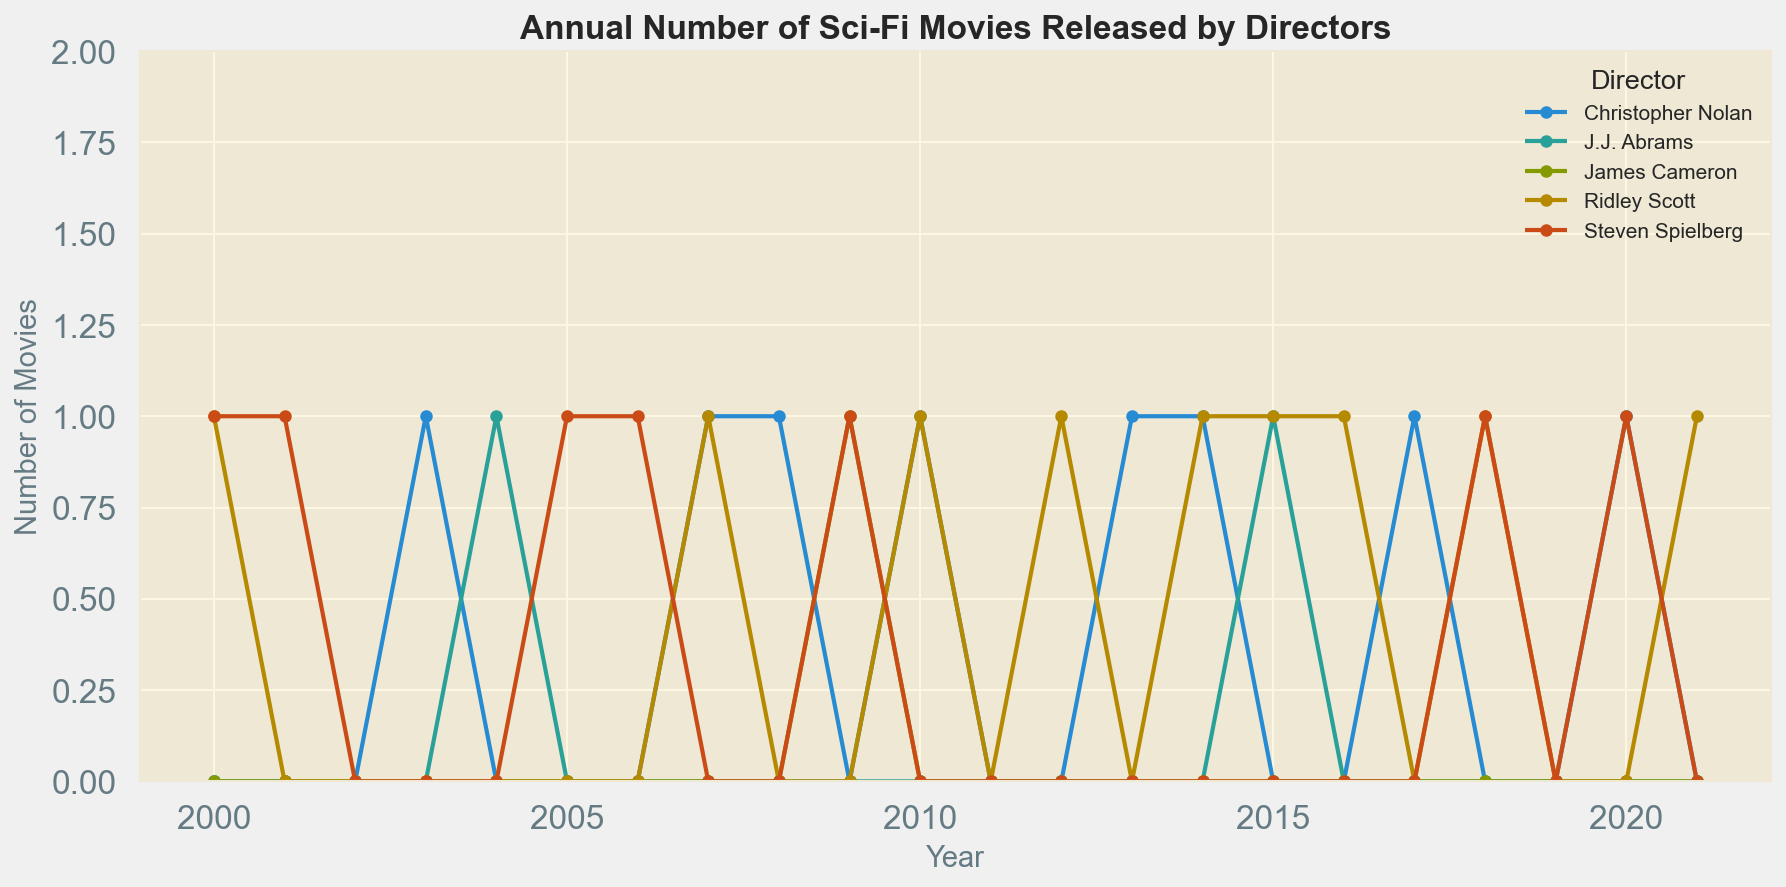What is the annual trend in the number of sci-fi movies released by Steven Spielberg from 2000 to 2021? Look at the line representing Steven Spielberg in the figure. Starting at one movie in 2000, the trend fluctuates with occasional years having one movie (2001, 2005, 2006, 2009, 2018, 2020) while most years have zero movies.
Answer: The trend fluctuates with a mix of zero and one movie, no clear upward or downward trend How did the number of sci-fi movies released by Christopher Nolan change between 2007 and 2010? Check the plot for Christopher Nolan. In 2007, he released one movie, this remained at one movie in 2008 and 2010, but zero movies were released in 2009.
Answer: Fluctuated between zero and one movie per year During which years did Ridley Scott release more sci-fi movies than J.J. Abrams? By examining the graph, compare Ridley Scott's and J.J. Abrams' lines. Notably, Ridley Scott released more movies in 2012 and 2016. In other years, their numbers of releases are either zero or the same.
Answer: 2012, 2016 What is the total number of sci-fi movies released by James Cameron from 2000 to 2021? Sum the number of movies released each year by James Cameron from the figure. He released movies only in 2009. Therefore, the total is one app + sum(0 for all other years).
Answer: 1 Which year had the highest number of sci-fi movies released across all the directors? Check the graph for the year(s) where the combined totals of releases for all directors peak. Note 2018, where both Steven Spielberg and Ridley Scott each released one movie.
Answer: 2018 What is the average number of sci-fi movies released annually by Christopher Nolan? Identify the total number of years he released movies (2003, 2007, 2008, 2010, 2013, 2014, 2017, 2020), calculate the sum of movies (add these years) and divide by the number of active years. (1+1+1+1+1+1+1+1)/8 = 1.
Answer: 1 Compare the total number of sci-fi movies released by Ridley Scott and J.J. Abrams from 2000 to 2021. Who released more and by how many? Add the total releases for Ridley Scott (7) and J.J. Abrams (3) and then find the difference between them.
Answer: Ridley Scott released 4 more movies What year saw both Christopher Nolan and Steven Spielberg release sci-fi movies? Identify the overlap in release years by examining both directors' plots. They both released movies in 2020.
Answer: 2020 In which year(s) did James Cameron release any sci-fi movies, and how does that compare to Ridley Scott's releases in the same year(s)? James Cameron released only in 2009, while Ridley Scott did not release any movies that year.
Answer: 2009, Ridley Scott released 0 movies that year Between which years did Steven Spielberg not release any sci-fi movies consecutively? Find the longest continuous segment in the plot where Steven Spielberg's line remains at zero. This can be seen from 2002 to 2004 and 2010 to 2017.
Answer: 2002 to 2004 and 2010 to 2017 